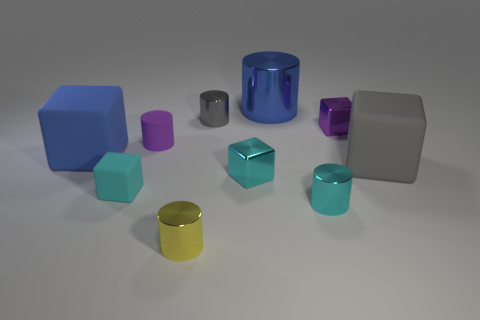Can you describe the lighting and shadows in the scene? The lighting in the scene is soft and diffused, coming from above, casting subtle shadows on the ground. The shadows are consistent with the size and shape of the objects, suggesting a single primary light source with possibly some ambient light filling in from the surroundings. 